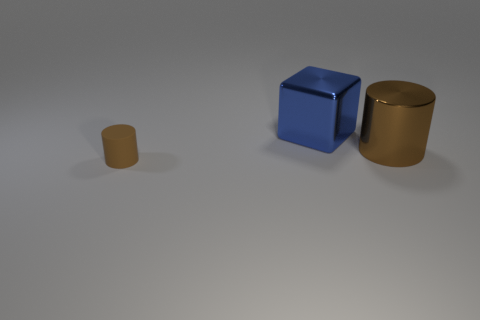Are there any other small things of the same shape as the small brown rubber thing?
Your response must be concise. No. There is a shiny thing that is the same size as the blue shiny block; what is its shape?
Offer a terse response. Cylinder. What number of things are either big objects or rubber objects?
Provide a succinct answer. 3. Are there any things?
Your answer should be compact. Yes. Are there fewer tiny purple rubber spheres than things?
Ensure brevity in your answer.  Yes. Are there any purple cylinders that have the same size as the brown metallic thing?
Your answer should be very brief. No. Does the blue shiny object have the same shape as the metal thing to the right of the cube?
Your answer should be very brief. No. What number of cubes are large blue metallic things or brown metallic objects?
Provide a short and direct response. 1. The large cylinder is what color?
Offer a terse response. Brown. Are there more small green balls than tiny rubber cylinders?
Your response must be concise. No. 